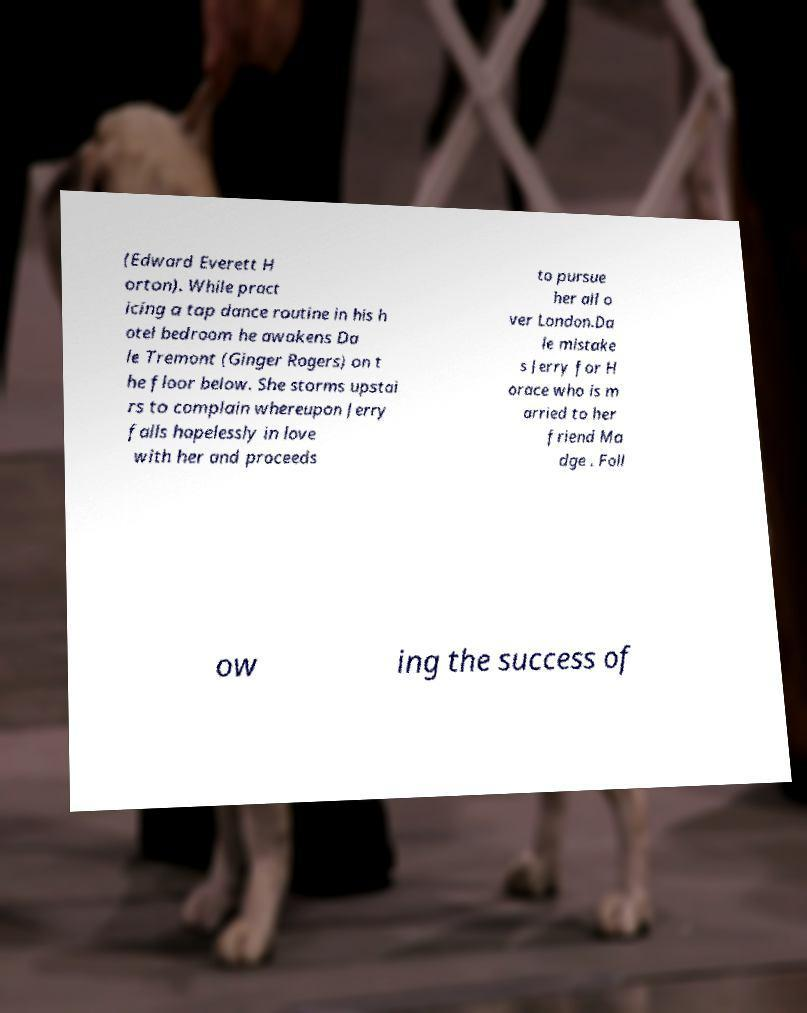Could you extract and type out the text from this image? (Edward Everett H orton). While pract icing a tap dance routine in his h otel bedroom he awakens Da le Tremont (Ginger Rogers) on t he floor below. She storms upstai rs to complain whereupon Jerry falls hopelessly in love with her and proceeds to pursue her all o ver London.Da le mistake s Jerry for H orace who is m arried to her friend Ma dge . Foll ow ing the success of 